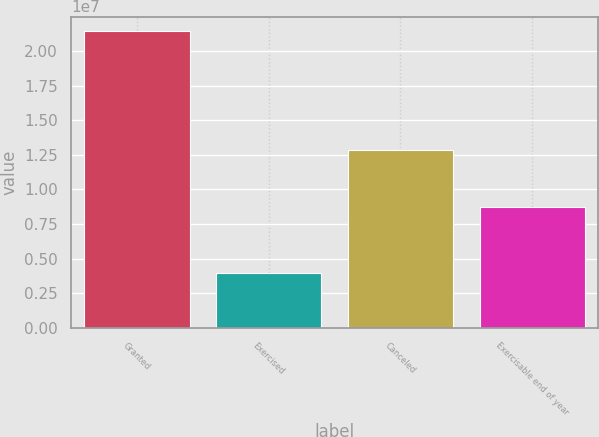<chart> <loc_0><loc_0><loc_500><loc_500><bar_chart><fcel>Granted<fcel>Exercised<fcel>Canceled<fcel>Exercisable end of year<nl><fcel>2.14267e+07<fcel>3.97795e+06<fcel>1.28596e+07<fcel>8.73664e+06<nl></chart> 